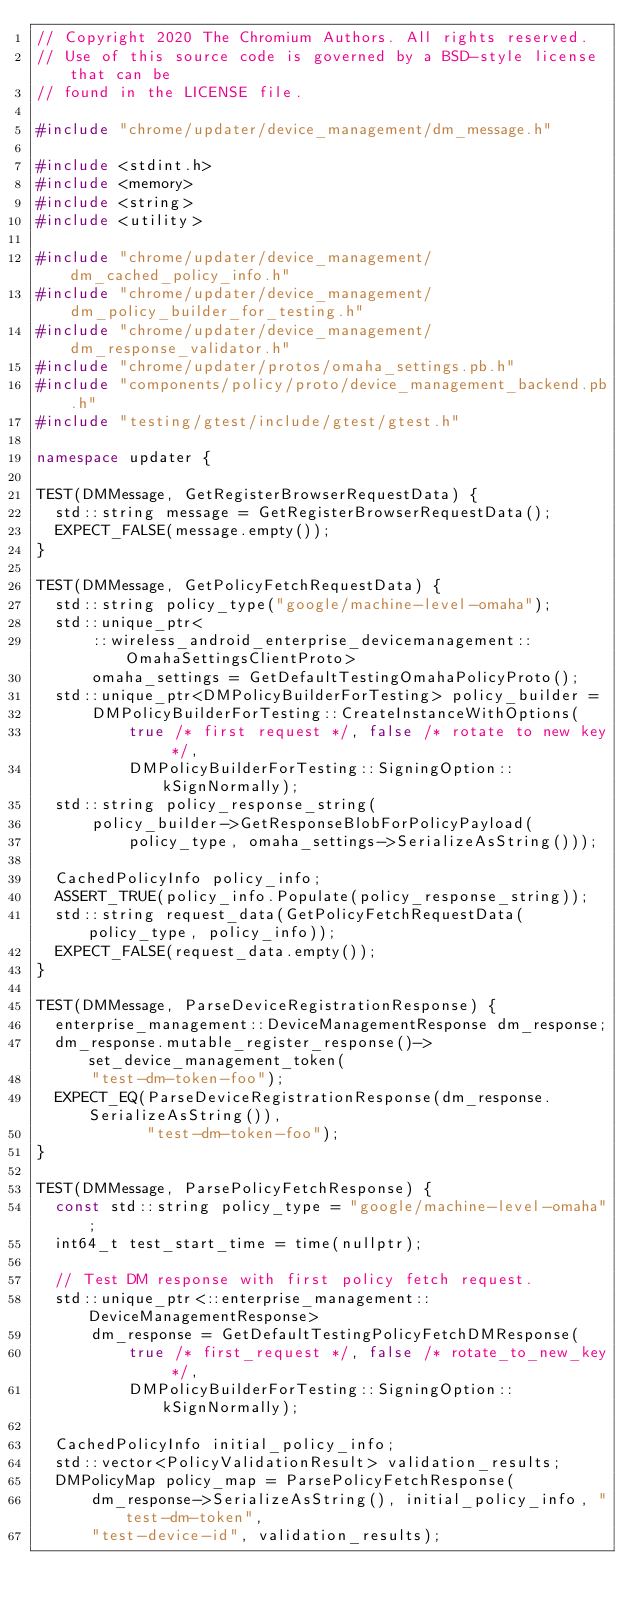<code> <loc_0><loc_0><loc_500><loc_500><_C++_>// Copyright 2020 The Chromium Authors. All rights reserved.
// Use of this source code is governed by a BSD-style license that can be
// found in the LICENSE file.

#include "chrome/updater/device_management/dm_message.h"

#include <stdint.h>
#include <memory>
#include <string>
#include <utility>

#include "chrome/updater/device_management/dm_cached_policy_info.h"
#include "chrome/updater/device_management/dm_policy_builder_for_testing.h"
#include "chrome/updater/device_management/dm_response_validator.h"
#include "chrome/updater/protos/omaha_settings.pb.h"
#include "components/policy/proto/device_management_backend.pb.h"
#include "testing/gtest/include/gtest/gtest.h"

namespace updater {

TEST(DMMessage, GetRegisterBrowserRequestData) {
  std::string message = GetRegisterBrowserRequestData();
  EXPECT_FALSE(message.empty());
}

TEST(DMMessage, GetPolicyFetchRequestData) {
  std::string policy_type("google/machine-level-omaha");
  std::unique_ptr<
      ::wireless_android_enterprise_devicemanagement::OmahaSettingsClientProto>
      omaha_settings = GetDefaultTestingOmahaPolicyProto();
  std::unique_ptr<DMPolicyBuilderForTesting> policy_builder =
      DMPolicyBuilderForTesting::CreateInstanceWithOptions(
          true /* first request */, false /* rotate to new key */,
          DMPolicyBuilderForTesting::SigningOption::kSignNormally);
  std::string policy_response_string(
      policy_builder->GetResponseBlobForPolicyPayload(
          policy_type, omaha_settings->SerializeAsString()));

  CachedPolicyInfo policy_info;
  ASSERT_TRUE(policy_info.Populate(policy_response_string));
  std::string request_data(GetPolicyFetchRequestData(policy_type, policy_info));
  EXPECT_FALSE(request_data.empty());
}

TEST(DMMessage, ParseDeviceRegistrationResponse) {
  enterprise_management::DeviceManagementResponse dm_response;
  dm_response.mutable_register_response()->set_device_management_token(
      "test-dm-token-foo");
  EXPECT_EQ(ParseDeviceRegistrationResponse(dm_response.SerializeAsString()),
            "test-dm-token-foo");
}

TEST(DMMessage, ParsePolicyFetchResponse) {
  const std::string policy_type = "google/machine-level-omaha";
  int64_t test_start_time = time(nullptr);

  // Test DM response with first policy fetch request.
  std::unique_ptr<::enterprise_management::DeviceManagementResponse>
      dm_response = GetDefaultTestingPolicyFetchDMResponse(
          true /* first_request */, false /* rotate_to_new_key */,
          DMPolicyBuilderForTesting::SigningOption::kSignNormally);

  CachedPolicyInfo initial_policy_info;
  std::vector<PolicyValidationResult> validation_results;
  DMPolicyMap policy_map = ParsePolicyFetchResponse(
      dm_response->SerializeAsString(), initial_policy_info, "test-dm-token",
      "test-device-id", validation_results);</code> 